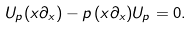<formula> <loc_0><loc_0><loc_500><loc_500>U _ { p } ( x \partial _ { x } ) - p \, ( x \partial _ { x } ) U _ { p } = 0 .</formula> 